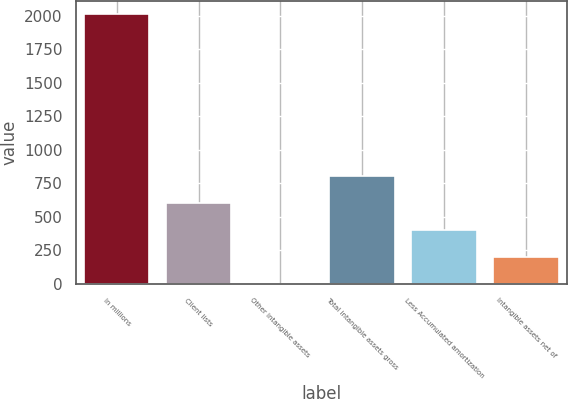<chart> <loc_0><loc_0><loc_500><loc_500><bar_chart><fcel>In millions<fcel>Client lists<fcel>Other intangible assets<fcel>Total intangible assets gross<fcel>Less Accumulated amortization<fcel>Intangible assets net of<nl><fcel>2013<fcel>605.58<fcel>2.4<fcel>806.64<fcel>404.52<fcel>203.46<nl></chart> 